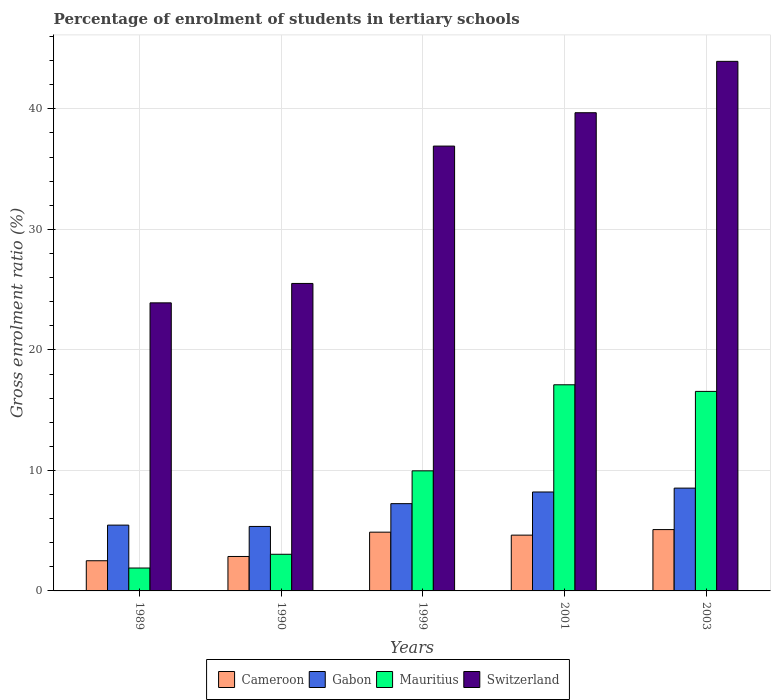Are the number of bars per tick equal to the number of legend labels?
Offer a very short reply. Yes. How many bars are there on the 3rd tick from the left?
Provide a succinct answer. 4. How many bars are there on the 3rd tick from the right?
Your answer should be compact. 4. In how many cases, is the number of bars for a given year not equal to the number of legend labels?
Your response must be concise. 0. What is the percentage of students enrolled in tertiary schools in Gabon in 2003?
Provide a short and direct response. 8.53. Across all years, what is the maximum percentage of students enrolled in tertiary schools in Switzerland?
Your response must be concise. 43.94. Across all years, what is the minimum percentage of students enrolled in tertiary schools in Mauritius?
Provide a succinct answer. 1.9. What is the total percentage of students enrolled in tertiary schools in Cameroon in the graph?
Provide a short and direct response. 19.96. What is the difference between the percentage of students enrolled in tertiary schools in Mauritius in 1989 and that in 2001?
Your answer should be compact. -15.21. What is the difference between the percentage of students enrolled in tertiary schools in Gabon in 2003 and the percentage of students enrolled in tertiary schools in Switzerland in 1990?
Provide a succinct answer. -16.98. What is the average percentage of students enrolled in tertiary schools in Gabon per year?
Provide a short and direct response. 6.96. In the year 1990, what is the difference between the percentage of students enrolled in tertiary schools in Gabon and percentage of students enrolled in tertiary schools in Cameroon?
Give a very brief answer. 2.49. In how many years, is the percentage of students enrolled in tertiary schools in Mauritius greater than 8 %?
Your answer should be compact. 3. What is the ratio of the percentage of students enrolled in tertiary schools in Gabon in 1999 to that in 2001?
Provide a short and direct response. 0.88. Is the percentage of students enrolled in tertiary schools in Cameroon in 1990 less than that in 1999?
Make the answer very short. Yes. What is the difference between the highest and the second highest percentage of students enrolled in tertiary schools in Gabon?
Provide a succinct answer. 0.32. What is the difference between the highest and the lowest percentage of students enrolled in tertiary schools in Mauritius?
Keep it short and to the point. 15.21. In how many years, is the percentage of students enrolled in tertiary schools in Switzerland greater than the average percentage of students enrolled in tertiary schools in Switzerland taken over all years?
Provide a short and direct response. 3. Is it the case that in every year, the sum of the percentage of students enrolled in tertiary schools in Switzerland and percentage of students enrolled in tertiary schools in Gabon is greater than the sum of percentage of students enrolled in tertiary schools in Cameroon and percentage of students enrolled in tertiary schools in Mauritius?
Offer a terse response. Yes. What does the 4th bar from the left in 1989 represents?
Your response must be concise. Switzerland. What does the 3rd bar from the right in 1989 represents?
Provide a succinct answer. Gabon. What is the difference between two consecutive major ticks on the Y-axis?
Provide a short and direct response. 10. What is the title of the graph?
Keep it short and to the point. Percentage of enrolment of students in tertiary schools. What is the Gross enrolment ratio (%) of Cameroon in 1989?
Offer a terse response. 2.5. What is the Gross enrolment ratio (%) of Gabon in 1989?
Provide a succinct answer. 5.46. What is the Gross enrolment ratio (%) of Mauritius in 1989?
Provide a short and direct response. 1.9. What is the Gross enrolment ratio (%) in Switzerland in 1989?
Your answer should be very brief. 23.9. What is the Gross enrolment ratio (%) of Cameroon in 1990?
Your answer should be very brief. 2.86. What is the Gross enrolment ratio (%) in Gabon in 1990?
Your response must be concise. 5.35. What is the Gross enrolment ratio (%) of Mauritius in 1990?
Provide a short and direct response. 3.04. What is the Gross enrolment ratio (%) of Switzerland in 1990?
Offer a terse response. 25.51. What is the Gross enrolment ratio (%) of Cameroon in 1999?
Offer a very short reply. 4.88. What is the Gross enrolment ratio (%) of Gabon in 1999?
Your response must be concise. 7.24. What is the Gross enrolment ratio (%) of Mauritius in 1999?
Your response must be concise. 9.97. What is the Gross enrolment ratio (%) of Switzerland in 1999?
Keep it short and to the point. 36.91. What is the Gross enrolment ratio (%) of Cameroon in 2001?
Offer a terse response. 4.63. What is the Gross enrolment ratio (%) of Gabon in 2001?
Provide a succinct answer. 8.21. What is the Gross enrolment ratio (%) in Mauritius in 2001?
Offer a terse response. 17.11. What is the Gross enrolment ratio (%) in Switzerland in 2001?
Your response must be concise. 39.68. What is the Gross enrolment ratio (%) in Cameroon in 2003?
Make the answer very short. 5.09. What is the Gross enrolment ratio (%) of Gabon in 2003?
Keep it short and to the point. 8.53. What is the Gross enrolment ratio (%) of Mauritius in 2003?
Provide a succinct answer. 16.56. What is the Gross enrolment ratio (%) in Switzerland in 2003?
Offer a very short reply. 43.94. Across all years, what is the maximum Gross enrolment ratio (%) in Cameroon?
Offer a terse response. 5.09. Across all years, what is the maximum Gross enrolment ratio (%) of Gabon?
Give a very brief answer. 8.53. Across all years, what is the maximum Gross enrolment ratio (%) of Mauritius?
Your answer should be very brief. 17.11. Across all years, what is the maximum Gross enrolment ratio (%) in Switzerland?
Provide a succinct answer. 43.94. Across all years, what is the minimum Gross enrolment ratio (%) in Cameroon?
Keep it short and to the point. 2.5. Across all years, what is the minimum Gross enrolment ratio (%) in Gabon?
Give a very brief answer. 5.35. Across all years, what is the minimum Gross enrolment ratio (%) in Mauritius?
Make the answer very short. 1.9. Across all years, what is the minimum Gross enrolment ratio (%) of Switzerland?
Provide a succinct answer. 23.9. What is the total Gross enrolment ratio (%) in Cameroon in the graph?
Your response must be concise. 19.96. What is the total Gross enrolment ratio (%) of Gabon in the graph?
Provide a short and direct response. 34.79. What is the total Gross enrolment ratio (%) in Mauritius in the graph?
Keep it short and to the point. 48.57. What is the total Gross enrolment ratio (%) of Switzerland in the graph?
Provide a succinct answer. 169.96. What is the difference between the Gross enrolment ratio (%) of Cameroon in 1989 and that in 1990?
Make the answer very short. -0.35. What is the difference between the Gross enrolment ratio (%) in Gabon in 1989 and that in 1990?
Keep it short and to the point. 0.11. What is the difference between the Gross enrolment ratio (%) in Mauritius in 1989 and that in 1990?
Your answer should be compact. -1.14. What is the difference between the Gross enrolment ratio (%) in Switzerland in 1989 and that in 1990?
Your answer should be compact. -1.61. What is the difference between the Gross enrolment ratio (%) in Cameroon in 1989 and that in 1999?
Your answer should be compact. -2.37. What is the difference between the Gross enrolment ratio (%) in Gabon in 1989 and that in 1999?
Offer a very short reply. -1.78. What is the difference between the Gross enrolment ratio (%) of Mauritius in 1989 and that in 1999?
Offer a very short reply. -8.07. What is the difference between the Gross enrolment ratio (%) of Switzerland in 1989 and that in 1999?
Give a very brief answer. -13.01. What is the difference between the Gross enrolment ratio (%) of Cameroon in 1989 and that in 2001?
Offer a terse response. -2.12. What is the difference between the Gross enrolment ratio (%) in Gabon in 1989 and that in 2001?
Your answer should be compact. -2.75. What is the difference between the Gross enrolment ratio (%) of Mauritius in 1989 and that in 2001?
Your answer should be compact. -15.21. What is the difference between the Gross enrolment ratio (%) in Switzerland in 1989 and that in 2001?
Give a very brief answer. -15.78. What is the difference between the Gross enrolment ratio (%) in Cameroon in 1989 and that in 2003?
Offer a very short reply. -2.58. What is the difference between the Gross enrolment ratio (%) of Gabon in 1989 and that in 2003?
Give a very brief answer. -3.07. What is the difference between the Gross enrolment ratio (%) in Mauritius in 1989 and that in 2003?
Offer a terse response. -14.66. What is the difference between the Gross enrolment ratio (%) in Switzerland in 1989 and that in 2003?
Provide a short and direct response. -20.04. What is the difference between the Gross enrolment ratio (%) in Cameroon in 1990 and that in 1999?
Offer a very short reply. -2.02. What is the difference between the Gross enrolment ratio (%) of Gabon in 1990 and that in 1999?
Offer a very short reply. -1.89. What is the difference between the Gross enrolment ratio (%) of Mauritius in 1990 and that in 1999?
Offer a terse response. -6.92. What is the difference between the Gross enrolment ratio (%) of Switzerland in 1990 and that in 1999?
Give a very brief answer. -11.4. What is the difference between the Gross enrolment ratio (%) of Cameroon in 1990 and that in 2001?
Provide a short and direct response. -1.77. What is the difference between the Gross enrolment ratio (%) in Gabon in 1990 and that in 2001?
Your answer should be very brief. -2.86. What is the difference between the Gross enrolment ratio (%) in Mauritius in 1990 and that in 2001?
Offer a terse response. -14.06. What is the difference between the Gross enrolment ratio (%) of Switzerland in 1990 and that in 2001?
Ensure brevity in your answer.  -14.17. What is the difference between the Gross enrolment ratio (%) of Cameroon in 1990 and that in 2003?
Provide a short and direct response. -2.23. What is the difference between the Gross enrolment ratio (%) of Gabon in 1990 and that in 2003?
Provide a short and direct response. -3.18. What is the difference between the Gross enrolment ratio (%) of Mauritius in 1990 and that in 2003?
Give a very brief answer. -13.51. What is the difference between the Gross enrolment ratio (%) of Switzerland in 1990 and that in 2003?
Give a very brief answer. -18.43. What is the difference between the Gross enrolment ratio (%) in Cameroon in 1999 and that in 2001?
Your response must be concise. 0.25. What is the difference between the Gross enrolment ratio (%) of Gabon in 1999 and that in 2001?
Your answer should be compact. -0.97. What is the difference between the Gross enrolment ratio (%) in Mauritius in 1999 and that in 2001?
Offer a very short reply. -7.14. What is the difference between the Gross enrolment ratio (%) of Switzerland in 1999 and that in 2001?
Your answer should be very brief. -2.77. What is the difference between the Gross enrolment ratio (%) of Cameroon in 1999 and that in 2003?
Your answer should be very brief. -0.21. What is the difference between the Gross enrolment ratio (%) in Gabon in 1999 and that in 2003?
Provide a short and direct response. -1.29. What is the difference between the Gross enrolment ratio (%) of Mauritius in 1999 and that in 2003?
Your answer should be compact. -6.59. What is the difference between the Gross enrolment ratio (%) in Switzerland in 1999 and that in 2003?
Provide a short and direct response. -7.03. What is the difference between the Gross enrolment ratio (%) of Cameroon in 2001 and that in 2003?
Offer a very short reply. -0.46. What is the difference between the Gross enrolment ratio (%) in Gabon in 2001 and that in 2003?
Give a very brief answer. -0.32. What is the difference between the Gross enrolment ratio (%) of Mauritius in 2001 and that in 2003?
Ensure brevity in your answer.  0.55. What is the difference between the Gross enrolment ratio (%) in Switzerland in 2001 and that in 2003?
Offer a terse response. -4.26. What is the difference between the Gross enrolment ratio (%) of Cameroon in 1989 and the Gross enrolment ratio (%) of Gabon in 1990?
Your response must be concise. -2.85. What is the difference between the Gross enrolment ratio (%) of Cameroon in 1989 and the Gross enrolment ratio (%) of Mauritius in 1990?
Your response must be concise. -0.54. What is the difference between the Gross enrolment ratio (%) in Cameroon in 1989 and the Gross enrolment ratio (%) in Switzerland in 1990?
Offer a terse response. -23.01. What is the difference between the Gross enrolment ratio (%) of Gabon in 1989 and the Gross enrolment ratio (%) of Mauritius in 1990?
Your response must be concise. 2.42. What is the difference between the Gross enrolment ratio (%) in Gabon in 1989 and the Gross enrolment ratio (%) in Switzerland in 1990?
Offer a terse response. -20.05. What is the difference between the Gross enrolment ratio (%) of Mauritius in 1989 and the Gross enrolment ratio (%) of Switzerland in 1990?
Provide a short and direct response. -23.61. What is the difference between the Gross enrolment ratio (%) of Cameroon in 1989 and the Gross enrolment ratio (%) of Gabon in 1999?
Give a very brief answer. -4.74. What is the difference between the Gross enrolment ratio (%) in Cameroon in 1989 and the Gross enrolment ratio (%) in Mauritius in 1999?
Your response must be concise. -7.46. What is the difference between the Gross enrolment ratio (%) of Cameroon in 1989 and the Gross enrolment ratio (%) of Switzerland in 1999?
Make the answer very short. -34.41. What is the difference between the Gross enrolment ratio (%) in Gabon in 1989 and the Gross enrolment ratio (%) in Mauritius in 1999?
Offer a very short reply. -4.5. What is the difference between the Gross enrolment ratio (%) in Gabon in 1989 and the Gross enrolment ratio (%) in Switzerland in 1999?
Offer a very short reply. -31.45. What is the difference between the Gross enrolment ratio (%) of Mauritius in 1989 and the Gross enrolment ratio (%) of Switzerland in 1999?
Provide a succinct answer. -35.01. What is the difference between the Gross enrolment ratio (%) of Cameroon in 1989 and the Gross enrolment ratio (%) of Gabon in 2001?
Provide a short and direct response. -5.7. What is the difference between the Gross enrolment ratio (%) of Cameroon in 1989 and the Gross enrolment ratio (%) of Mauritius in 2001?
Keep it short and to the point. -14.6. What is the difference between the Gross enrolment ratio (%) in Cameroon in 1989 and the Gross enrolment ratio (%) in Switzerland in 2001?
Ensure brevity in your answer.  -37.18. What is the difference between the Gross enrolment ratio (%) of Gabon in 1989 and the Gross enrolment ratio (%) of Mauritius in 2001?
Ensure brevity in your answer.  -11.64. What is the difference between the Gross enrolment ratio (%) of Gabon in 1989 and the Gross enrolment ratio (%) of Switzerland in 2001?
Your answer should be very brief. -34.22. What is the difference between the Gross enrolment ratio (%) in Mauritius in 1989 and the Gross enrolment ratio (%) in Switzerland in 2001?
Ensure brevity in your answer.  -37.78. What is the difference between the Gross enrolment ratio (%) of Cameroon in 1989 and the Gross enrolment ratio (%) of Gabon in 2003?
Your answer should be compact. -6.03. What is the difference between the Gross enrolment ratio (%) of Cameroon in 1989 and the Gross enrolment ratio (%) of Mauritius in 2003?
Ensure brevity in your answer.  -14.05. What is the difference between the Gross enrolment ratio (%) of Cameroon in 1989 and the Gross enrolment ratio (%) of Switzerland in 2003?
Your response must be concise. -41.44. What is the difference between the Gross enrolment ratio (%) in Gabon in 1989 and the Gross enrolment ratio (%) in Mauritius in 2003?
Your answer should be compact. -11.1. What is the difference between the Gross enrolment ratio (%) of Gabon in 1989 and the Gross enrolment ratio (%) of Switzerland in 2003?
Keep it short and to the point. -38.48. What is the difference between the Gross enrolment ratio (%) in Mauritius in 1989 and the Gross enrolment ratio (%) in Switzerland in 2003?
Keep it short and to the point. -42.04. What is the difference between the Gross enrolment ratio (%) in Cameroon in 1990 and the Gross enrolment ratio (%) in Gabon in 1999?
Your response must be concise. -4.38. What is the difference between the Gross enrolment ratio (%) in Cameroon in 1990 and the Gross enrolment ratio (%) in Mauritius in 1999?
Make the answer very short. -7.11. What is the difference between the Gross enrolment ratio (%) in Cameroon in 1990 and the Gross enrolment ratio (%) in Switzerland in 1999?
Provide a short and direct response. -34.05. What is the difference between the Gross enrolment ratio (%) of Gabon in 1990 and the Gross enrolment ratio (%) of Mauritius in 1999?
Provide a succinct answer. -4.62. What is the difference between the Gross enrolment ratio (%) of Gabon in 1990 and the Gross enrolment ratio (%) of Switzerland in 1999?
Make the answer very short. -31.56. What is the difference between the Gross enrolment ratio (%) in Mauritius in 1990 and the Gross enrolment ratio (%) in Switzerland in 1999?
Provide a short and direct response. -33.87. What is the difference between the Gross enrolment ratio (%) of Cameroon in 1990 and the Gross enrolment ratio (%) of Gabon in 2001?
Your answer should be very brief. -5.35. What is the difference between the Gross enrolment ratio (%) of Cameroon in 1990 and the Gross enrolment ratio (%) of Mauritius in 2001?
Your answer should be compact. -14.25. What is the difference between the Gross enrolment ratio (%) in Cameroon in 1990 and the Gross enrolment ratio (%) in Switzerland in 2001?
Make the answer very short. -36.82. What is the difference between the Gross enrolment ratio (%) in Gabon in 1990 and the Gross enrolment ratio (%) in Mauritius in 2001?
Offer a terse response. -11.76. What is the difference between the Gross enrolment ratio (%) of Gabon in 1990 and the Gross enrolment ratio (%) of Switzerland in 2001?
Provide a short and direct response. -34.33. What is the difference between the Gross enrolment ratio (%) in Mauritius in 1990 and the Gross enrolment ratio (%) in Switzerland in 2001?
Provide a succinct answer. -36.64. What is the difference between the Gross enrolment ratio (%) in Cameroon in 1990 and the Gross enrolment ratio (%) in Gabon in 2003?
Provide a succinct answer. -5.67. What is the difference between the Gross enrolment ratio (%) in Cameroon in 1990 and the Gross enrolment ratio (%) in Mauritius in 2003?
Ensure brevity in your answer.  -13.7. What is the difference between the Gross enrolment ratio (%) of Cameroon in 1990 and the Gross enrolment ratio (%) of Switzerland in 2003?
Your response must be concise. -41.09. What is the difference between the Gross enrolment ratio (%) of Gabon in 1990 and the Gross enrolment ratio (%) of Mauritius in 2003?
Offer a very short reply. -11.21. What is the difference between the Gross enrolment ratio (%) of Gabon in 1990 and the Gross enrolment ratio (%) of Switzerland in 2003?
Ensure brevity in your answer.  -38.59. What is the difference between the Gross enrolment ratio (%) in Mauritius in 1990 and the Gross enrolment ratio (%) in Switzerland in 2003?
Your answer should be compact. -40.9. What is the difference between the Gross enrolment ratio (%) of Cameroon in 1999 and the Gross enrolment ratio (%) of Gabon in 2001?
Your response must be concise. -3.33. What is the difference between the Gross enrolment ratio (%) in Cameroon in 1999 and the Gross enrolment ratio (%) in Mauritius in 2001?
Your answer should be compact. -12.23. What is the difference between the Gross enrolment ratio (%) in Cameroon in 1999 and the Gross enrolment ratio (%) in Switzerland in 2001?
Give a very brief answer. -34.81. What is the difference between the Gross enrolment ratio (%) in Gabon in 1999 and the Gross enrolment ratio (%) in Mauritius in 2001?
Make the answer very short. -9.86. What is the difference between the Gross enrolment ratio (%) of Gabon in 1999 and the Gross enrolment ratio (%) of Switzerland in 2001?
Provide a short and direct response. -32.44. What is the difference between the Gross enrolment ratio (%) of Mauritius in 1999 and the Gross enrolment ratio (%) of Switzerland in 2001?
Keep it short and to the point. -29.72. What is the difference between the Gross enrolment ratio (%) of Cameroon in 1999 and the Gross enrolment ratio (%) of Gabon in 2003?
Give a very brief answer. -3.65. What is the difference between the Gross enrolment ratio (%) of Cameroon in 1999 and the Gross enrolment ratio (%) of Mauritius in 2003?
Your answer should be very brief. -11.68. What is the difference between the Gross enrolment ratio (%) in Cameroon in 1999 and the Gross enrolment ratio (%) in Switzerland in 2003?
Keep it short and to the point. -39.07. What is the difference between the Gross enrolment ratio (%) of Gabon in 1999 and the Gross enrolment ratio (%) of Mauritius in 2003?
Your answer should be very brief. -9.31. What is the difference between the Gross enrolment ratio (%) of Gabon in 1999 and the Gross enrolment ratio (%) of Switzerland in 2003?
Make the answer very short. -36.7. What is the difference between the Gross enrolment ratio (%) in Mauritius in 1999 and the Gross enrolment ratio (%) in Switzerland in 2003?
Offer a terse response. -33.98. What is the difference between the Gross enrolment ratio (%) in Cameroon in 2001 and the Gross enrolment ratio (%) in Gabon in 2003?
Offer a terse response. -3.9. What is the difference between the Gross enrolment ratio (%) of Cameroon in 2001 and the Gross enrolment ratio (%) of Mauritius in 2003?
Offer a terse response. -11.93. What is the difference between the Gross enrolment ratio (%) of Cameroon in 2001 and the Gross enrolment ratio (%) of Switzerland in 2003?
Provide a short and direct response. -39.31. What is the difference between the Gross enrolment ratio (%) in Gabon in 2001 and the Gross enrolment ratio (%) in Mauritius in 2003?
Offer a very short reply. -8.35. What is the difference between the Gross enrolment ratio (%) in Gabon in 2001 and the Gross enrolment ratio (%) in Switzerland in 2003?
Provide a succinct answer. -35.73. What is the difference between the Gross enrolment ratio (%) of Mauritius in 2001 and the Gross enrolment ratio (%) of Switzerland in 2003?
Offer a terse response. -26.84. What is the average Gross enrolment ratio (%) of Cameroon per year?
Give a very brief answer. 3.99. What is the average Gross enrolment ratio (%) of Gabon per year?
Provide a succinct answer. 6.96. What is the average Gross enrolment ratio (%) of Mauritius per year?
Keep it short and to the point. 9.71. What is the average Gross enrolment ratio (%) in Switzerland per year?
Provide a short and direct response. 33.99. In the year 1989, what is the difference between the Gross enrolment ratio (%) of Cameroon and Gross enrolment ratio (%) of Gabon?
Offer a terse response. -2.96. In the year 1989, what is the difference between the Gross enrolment ratio (%) in Cameroon and Gross enrolment ratio (%) in Mauritius?
Give a very brief answer. 0.6. In the year 1989, what is the difference between the Gross enrolment ratio (%) of Cameroon and Gross enrolment ratio (%) of Switzerland?
Your answer should be compact. -21.4. In the year 1989, what is the difference between the Gross enrolment ratio (%) in Gabon and Gross enrolment ratio (%) in Mauritius?
Make the answer very short. 3.56. In the year 1989, what is the difference between the Gross enrolment ratio (%) of Gabon and Gross enrolment ratio (%) of Switzerland?
Your answer should be compact. -18.44. In the year 1989, what is the difference between the Gross enrolment ratio (%) in Mauritius and Gross enrolment ratio (%) in Switzerland?
Your response must be concise. -22. In the year 1990, what is the difference between the Gross enrolment ratio (%) of Cameroon and Gross enrolment ratio (%) of Gabon?
Provide a short and direct response. -2.49. In the year 1990, what is the difference between the Gross enrolment ratio (%) of Cameroon and Gross enrolment ratio (%) of Mauritius?
Your answer should be compact. -0.18. In the year 1990, what is the difference between the Gross enrolment ratio (%) in Cameroon and Gross enrolment ratio (%) in Switzerland?
Your response must be concise. -22.66. In the year 1990, what is the difference between the Gross enrolment ratio (%) in Gabon and Gross enrolment ratio (%) in Mauritius?
Ensure brevity in your answer.  2.31. In the year 1990, what is the difference between the Gross enrolment ratio (%) of Gabon and Gross enrolment ratio (%) of Switzerland?
Offer a terse response. -20.16. In the year 1990, what is the difference between the Gross enrolment ratio (%) in Mauritius and Gross enrolment ratio (%) in Switzerland?
Provide a succinct answer. -22.47. In the year 1999, what is the difference between the Gross enrolment ratio (%) in Cameroon and Gross enrolment ratio (%) in Gabon?
Your answer should be compact. -2.37. In the year 1999, what is the difference between the Gross enrolment ratio (%) in Cameroon and Gross enrolment ratio (%) in Mauritius?
Offer a very short reply. -5.09. In the year 1999, what is the difference between the Gross enrolment ratio (%) of Cameroon and Gross enrolment ratio (%) of Switzerland?
Your answer should be very brief. -32.04. In the year 1999, what is the difference between the Gross enrolment ratio (%) in Gabon and Gross enrolment ratio (%) in Mauritius?
Your response must be concise. -2.72. In the year 1999, what is the difference between the Gross enrolment ratio (%) in Gabon and Gross enrolment ratio (%) in Switzerland?
Offer a very short reply. -29.67. In the year 1999, what is the difference between the Gross enrolment ratio (%) in Mauritius and Gross enrolment ratio (%) in Switzerland?
Offer a terse response. -26.95. In the year 2001, what is the difference between the Gross enrolment ratio (%) of Cameroon and Gross enrolment ratio (%) of Gabon?
Provide a succinct answer. -3.58. In the year 2001, what is the difference between the Gross enrolment ratio (%) in Cameroon and Gross enrolment ratio (%) in Mauritius?
Offer a very short reply. -12.48. In the year 2001, what is the difference between the Gross enrolment ratio (%) of Cameroon and Gross enrolment ratio (%) of Switzerland?
Your answer should be compact. -35.05. In the year 2001, what is the difference between the Gross enrolment ratio (%) in Gabon and Gross enrolment ratio (%) in Mauritius?
Provide a succinct answer. -8.9. In the year 2001, what is the difference between the Gross enrolment ratio (%) of Gabon and Gross enrolment ratio (%) of Switzerland?
Your response must be concise. -31.47. In the year 2001, what is the difference between the Gross enrolment ratio (%) of Mauritius and Gross enrolment ratio (%) of Switzerland?
Offer a very short reply. -22.58. In the year 2003, what is the difference between the Gross enrolment ratio (%) of Cameroon and Gross enrolment ratio (%) of Gabon?
Provide a short and direct response. -3.44. In the year 2003, what is the difference between the Gross enrolment ratio (%) in Cameroon and Gross enrolment ratio (%) in Mauritius?
Offer a terse response. -11.47. In the year 2003, what is the difference between the Gross enrolment ratio (%) of Cameroon and Gross enrolment ratio (%) of Switzerland?
Your answer should be very brief. -38.85. In the year 2003, what is the difference between the Gross enrolment ratio (%) in Gabon and Gross enrolment ratio (%) in Mauritius?
Your response must be concise. -8.03. In the year 2003, what is the difference between the Gross enrolment ratio (%) of Gabon and Gross enrolment ratio (%) of Switzerland?
Ensure brevity in your answer.  -35.41. In the year 2003, what is the difference between the Gross enrolment ratio (%) of Mauritius and Gross enrolment ratio (%) of Switzerland?
Your answer should be compact. -27.39. What is the ratio of the Gross enrolment ratio (%) in Cameroon in 1989 to that in 1990?
Provide a succinct answer. 0.88. What is the ratio of the Gross enrolment ratio (%) of Gabon in 1989 to that in 1990?
Your answer should be compact. 1.02. What is the ratio of the Gross enrolment ratio (%) of Mauritius in 1989 to that in 1990?
Your answer should be very brief. 0.62. What is the ratio of the Gross enrolment ratio (%) of Switzerland in 1989 to that in 1990?
Provide a short and direct response. 0.94. What is the ratio of the Gross enrolment ratio (%) in Cameroon in 1989 to that in 1999?
Make the answer very short. 0.51. What is the ratio of the Gross enrolment ratio (%) of Gabon in 1989 to that in 1999?
Provide a short and direct response. 0.75. What is the ratio of the Gross enrolment ratio (%) in Mauritius in 1989 to that in 1999?
Your answer should be compact. 0.19. What is the ratio of the Gross enrolment ratio (%) in Switzerland in 1989 to that in 1999?
Keep it short and to the point. 0.65. What is the ratio of the Gross enrolment ratio (%) of Cameroon in 1989 to that in 2001?
Your response must be concise. 0.54. What is the ratio of the Gross enrolment ratio (%) of Gabon in 1989 to that in 2001?
Provide a succinct answer. 0.67. What is the ratio of the Gross enrolment ratio (%) in Switzerland in 1989 to that in 2001?
Ensure brevity in your answer.  0.6. What is the ratio of the Gross enrolment ratio (%) in Cameroon in 1989 to that in 2003?
Provide a succinct answer. 0.49. What is the ratio of the Gross enrolment ratio (%) of Gabon in 1989 to that in 2003?
Your answer should be very brief. 0.64. What is the ratio of the Gross enrolment ratio (%) in Mauritius in 1989 to that in 2003?
Your answer should be compact. 0.11. What is the ratio of the Gross enrolment ratio (%) in Switzerland in 1989 to that in 2003?
Make the answer very short. 0.54. What is the ratio of the Gross enrolment ratio (%) of Cameroon in 1990 to that in 1999?
Your answer should be very brief. 0.59. What is the ratio of the Gross enrolment ratio (%) in Gabon in 1990 to that in 1999?
Your answer should be compact. 0.74. What is the ratio of the Gross enrolment ratio (%) in Mauritius in 1990 to that in 1999?
Your answer should be very brief. 0.31. What is the ratio of the Gross enrolment ratio (%) of Switzerland in 1990 to that in 1999?
Your answer should be compact. 0.69. What is the ratio of the Gross enrolment ratio (%) in Cameroon in 1990 to that in 2001?
Your answer should be very brief. 0.62. What is the ratio of the Gross enrolment ratio (%) of Gabon in 1990 to that in 2001?
Make the answer very short. 0.65. What is the ratio of the Gross enrolment ratio (%) of Mauritius in 1990 to that in 2001?
Provide a succinct answer. 0.18. What is the ratio of the Gross enrolment ratio (%) in Switzerland in 1990 to that in 2001?
Give a very brief answer. 0.64. What is the ratio of the Gross enrolment ratio (%) of Cameroon in 1990 to that in 2003?
Your answer should be compact. 0.56. What is the ratio of the Gross enrolment ratio (%) in Gabon in 1990 to that in 2003?
Your response must be concise. 0.63. What is the ratio of the Gross enrolment ratio (%) in Mauritius in 1990 to that in 2003?
Offer a terse response. 0.18. What is the ratio of the Gross enrolment ratio (%) of Switzerland in 1990 to that in 2003?
Provide a short and direct response. 0.58. What is the ratio of the Gross enrolment ratio (%) in Cameroon in 1999 to that in 2001?
Make the answer very short. 1.05. What is the ratio of the Gross enrolment ratio (%) in Gabon in 1999 to that in 2001?
Offer a very short reply. 0.88. What is the ratio of the Gross enrolment ratio (%) of Mauritius in 1999 to that in 2001?
Ensure brevity in your answer.  0.58. What is the ratio of the Gross enrolment ratio (%) in Switzerland in 1999 to that in 2001?
Offer a very short reply. 0.93. What is the ratio of the Gross enrolment ratio (%) in Cameroon in 1999 to that in 2003?
Provide a succinct answer. 0.96. What is the ratio of the Gross enrolment ratio (%) of Gabon in 1999 to that in 2003?
Your response must be concise. 0.85. What is the ratio of the Gross enrolment ratio (%) in Mauritius in 1999 to that in 2003?
Give a very brief answer. 0.6. What is the ratio of the Gross enrolment ratio (%) of Switzerland in 1999 to that in 2003?
Make the answer very short. 0.84. What is the ratio of the Gross enrolment ratio (%) of Cameroon in 2001 to that in 2003?
Your response must be concise. 0.91. What is the ratio of the Gross enrolment ratio (%) in Gabon in 2001 to that in 2003?
Give a very brief answer. 0.96. What is the ratio of the Gross enrolment ratio (%) in Mauritius in 2001 to that in 2003?
Give a very brief answer. 1.03. What is the ratio of the Gross enrolment ratio (%) of Switzerland in 2001 to that in 2003?
Keep it short and to the point. 0.9. What is the difference between the highest and the second highest Gross enrolment ratio (%) in Cameroon?
Provide a succinct answer. 0.21. What is the difference between the highest and the second highest Gross enrolment ratio (%) of Gabon?
Your answer should be compact. 0.32. What is the difference between the highest and the second highest Gross enrolment ratio (%) of Mauritius?
Give a very brief answer. 0.55. What is the difference between the highest and the second highest Gross enrolment ratio (%) of Switzerland?
Make the answer very short. 4.26. What is the difference between the highest and the lowest Gross enrolment ratio (%) in Cameroon?
Provide a short and direct response. 2.58. What is the difference between the highest and the lowest Gross enrolment ratio (%) in Gabon?
Your answer should be very brief. 3.18. What is the difference between the highest and the lowest Gross enrolment ratio (%) of Mauritius?
Provide a succinct answer. 15.21. What is the difference between the highest and the lowest Gross enrolment ratio (%) of Switzerland?
Offer a very short reply. 20.04. 